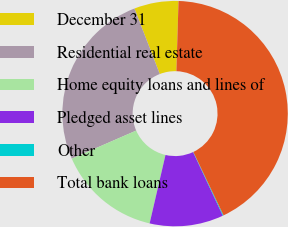Convert chart. <chart><loc_0><loc_0><loc_500><loc_500><pie_chart><fcel>December 31<fcel>Residential real estate<fcel>Home equity loans and lines of<fcel>Pledged asset lines<fcel>Other<fcel>Total bank loans<nl><fcel>6.36%<fcel>25.67%<fcel>14.83%<fcel>10.59%<fcel>0.11%<fcel>42.44%<nl></chart> 